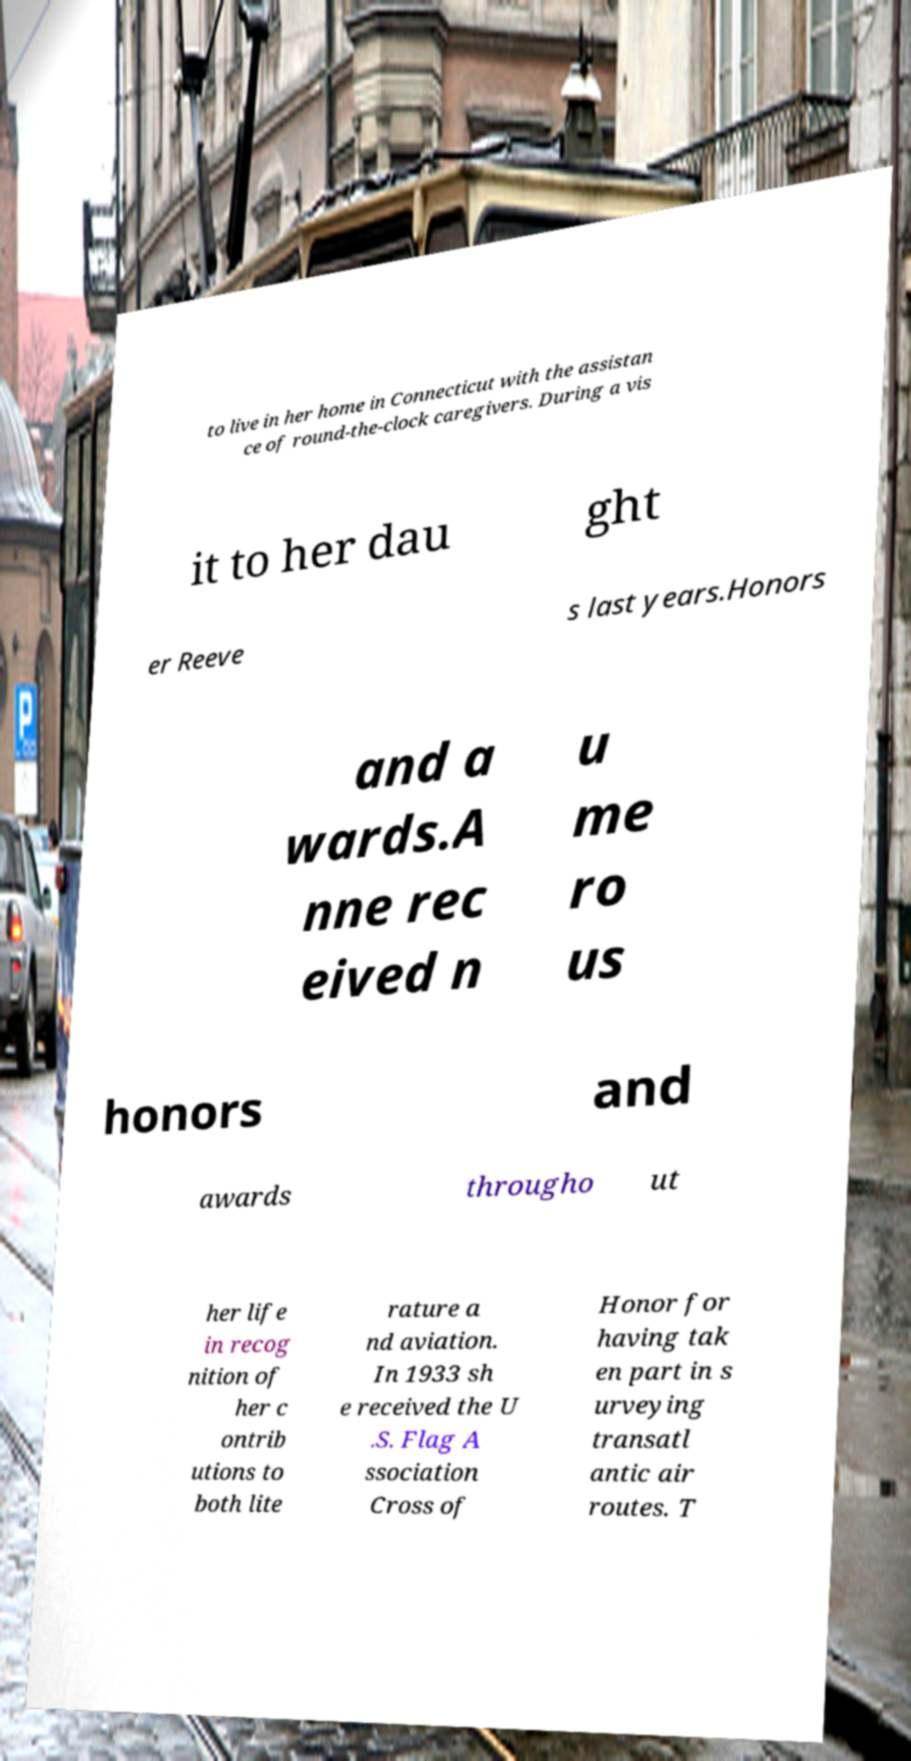Please read and relay the text visible in this image. What does it say? to live in her home in Connecticut with the assistan ce of round-the-clock caregivers. During a vis it to her dau ght er Reeve s last years.Honors and a wards.A nne rec eived n u me ro us honors and awards througho ut her life in recog nition of her c ontrib utions to both lite rature a nd aviation. In 1933 sh e received the U .S. Flag A ssociation Cross of Honor for having tak en part in s urveying transatl antic air routes. T 